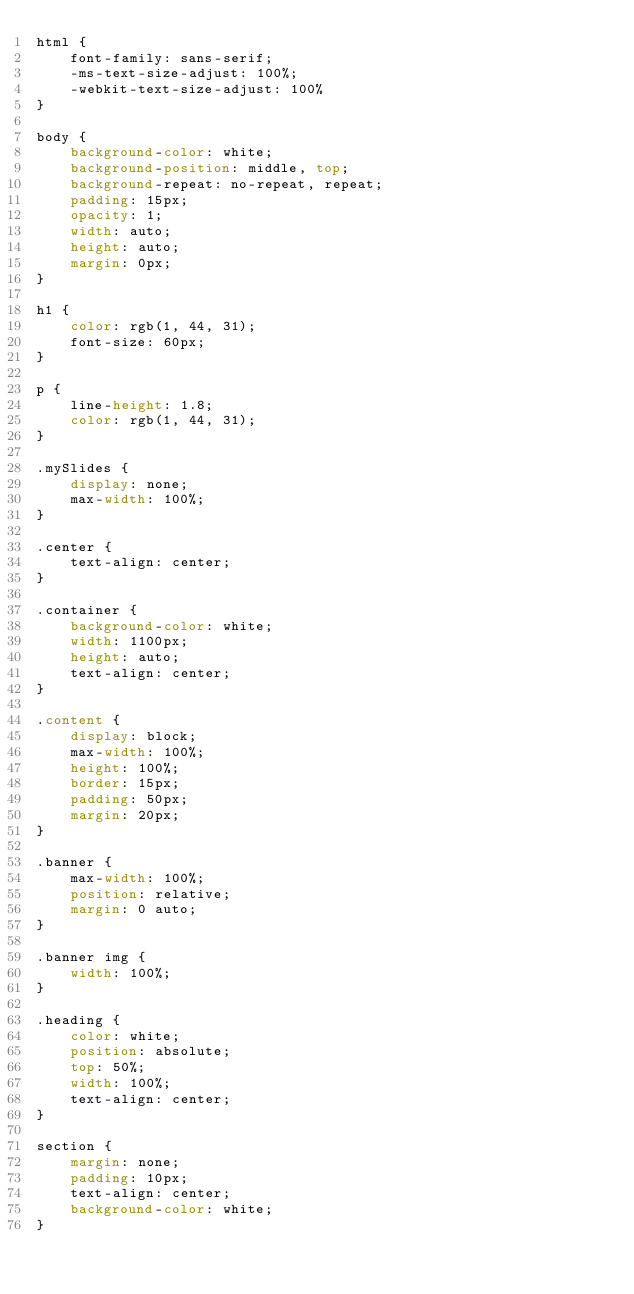<code> <loc_0><loc_0><loc_500><loc_500><_CSS_>html {
    font-family: sans-serif;
    -ms-text-size-adjust: 100%;
    -webkit-text-size-adjust: 100%
}

body {
    background-color: white;
    background-position: middle, top;
    background-repeat: no-repeat, repeat;
    padding: 15px;
    opacity: 1;
    width: auto;
    height: auto;
    margin: 0px;
}

h1 {
    color: rgb(1, 44, 31);
    font-size: 60px;
}

p {
    line-height: 1.8;
    color: rgb(1, 44, 31);
}

.mySlides {
    display: none;
    max-width: 100%;
}

.center {
    text-align: center;
}

.container {
    background-color: white;
    width: 1100px;
    height: auto;
    text-align: center;
}

.content {
    display: block;
    max-width: 100%;
    height: 100%;
    border: 15px;
    padding: 50px;
    margin: 20px;
}

.banner {
    max-width: 100%;
    position: relative;
    margin: 0 auto;
}

.banner img {
    width: 100%;
}

.heading {
    color: white;
    position: absolute;
    top: 50%;
    width: 100%;
    text-align: center;
}

section {
    margin: none;
    padding: 10px;
    text-align: center;
    background-color: white;
}</code> 